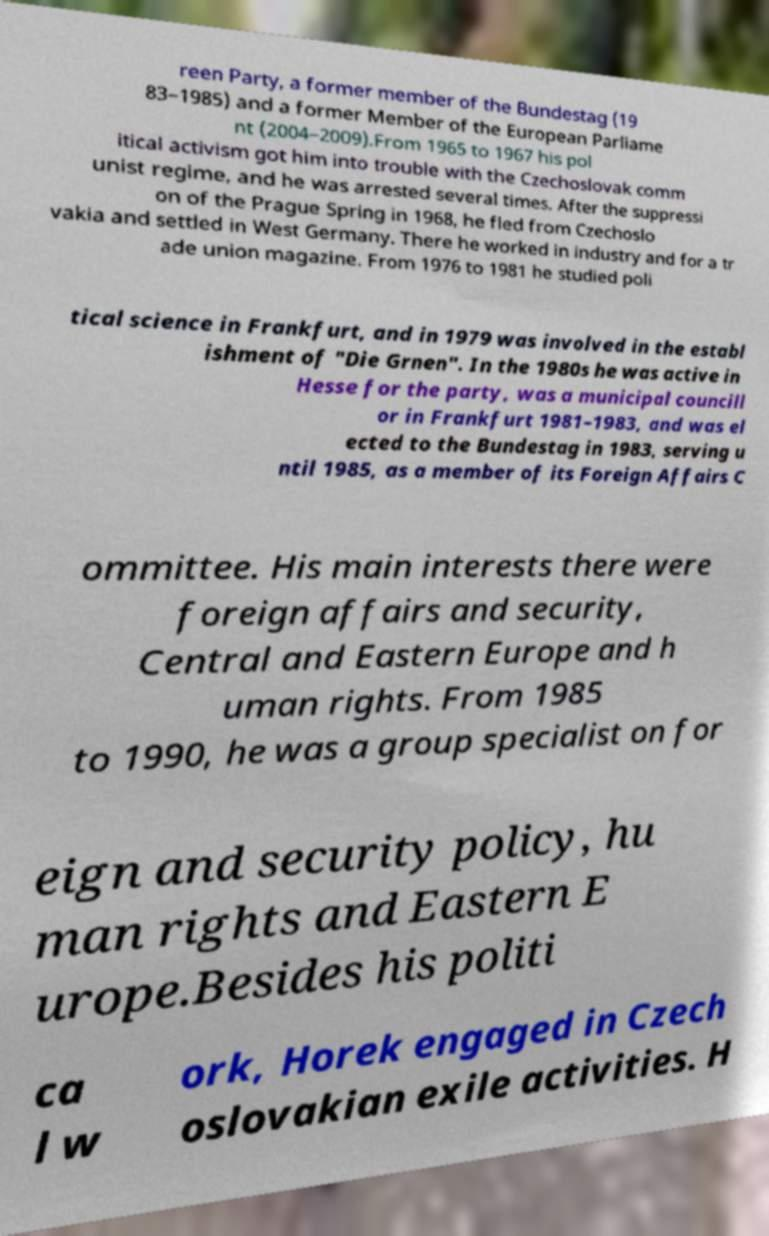There's text embedded in this image that I need extracted. Can you transcribe it verbatim? reen Party, a former member of the Bundestag (19 83–1985) and a former Member of the European Parliame nt (2004–2009).From 1965 to 1967 his pol itical activism got him into trouble with the Czechoslovak comm unist regime, and he was arrested several times. After the suppressi on of the Prague Spring in 1968, he fled from Czechoslo vakia and settled in West Germany. There he worked in industry and for a tr ade union magazine. From 1976 to 1981 he studied poli tical science in Frankfurt, and in 1979 was involved in the establ ishment of "Die Grnen". In the 1980s he was active in Hesse for the party, was a municipal councill or in Frankfurt 1981–1983, and was el ected to the Bundestag in 1983, serving u ntil 1985, as a member of its Foreign Affairs C ommittee. His main interests there were foreign affairs and security, Central and Eastern Europe and h uman rights. From 1985 to 1990, he was a group specialist on for eign and security policy, hu man rights and Eastern E urope.Besides his politi ca l w ork, Horek engaged in Czech oslovakian exile activities. H 